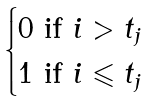Convert formula to latex. <formula><loc_0><loc_0><loc_500><loc_500>\begin{cases} 0 \text { if $i>t_{j}$} \\ 1 \text { if $i\leqslant t_{j}$} \end{cases}</formula> 